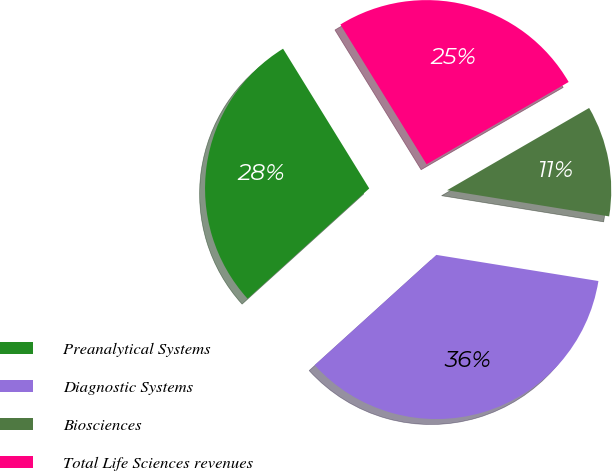Convert chart to OTSL. <chart><loc_0><loc_0><loc_500><loc_500><pie_chart><fcel>Preanalytical Systems<fcel>Diagnostic Systems<fcel>Biosciences<fcel>Total Life Sciences revenues<nl><fcel>27.92%<fcel>35.74%<fcel>10.9%<fcel>25.44%<nl></chart> 